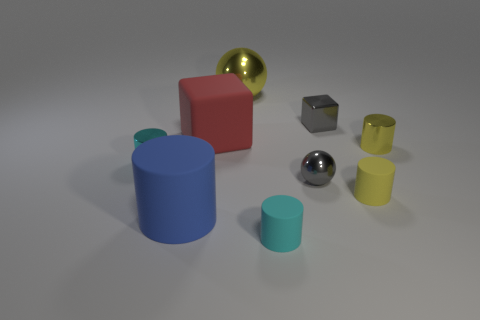The yellow thing that is to the left of the tiny yellow metallic cylinder and in front of the large ball has what shape?
Your response must be concise. Cylinder. What size is the matte cylinder that is left of the yellow shiny ball on the right side of the big blue matte thing?
Keep it short and to the point. Large. What number of blue rubber things have the same shape as the red object?
Offer a very short reply. 0. Is the shiny block the same color as the small sphere?
Give a very brief answer. Yes. Are there any things of the same color as the tiny ball?
Make the answer very short. Yes. Is the blue cylinder in front of the small gray metallic cube made of the same material as the cube that is in front of the metallic cube?
Make the answer very short. Yes. What color is the tiny ball?
Your answer should be compact. Gray. There is a shiny cylinder on the right side of the tiny cyan cylinder on the right side of the yellow thing behind the big red object; what is its size?
Make the answer very short. Small. How many other objects are there of the same size as the gray block?
Offer a very short reply. 5. What number of cyan cylinders are made of the same material as the gray block?
Give a very brief answer. 1. 